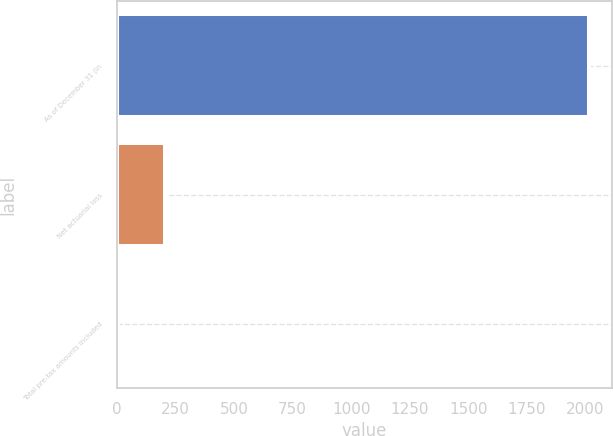Convert chart. <chart><loc_0><loc_0><loc_500><loc_500><bar_chart><fcel>As of December 31 (in<fcel>Net actuarial loss<fcel>Total pre-tax amounts included<nl><fcel>2014<fcel>205.81<fcel>4.9<nl></chart> 